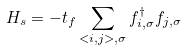Convert formula to latex. <formula><loc_0><loc_0><loc_500><loc_500>H _ { s } = - t _ { f } \sum _ { < i , j > , \sigma } f ^ { \dagger } _ { i , \sigma } f _ { j , \sigma }</formula> 